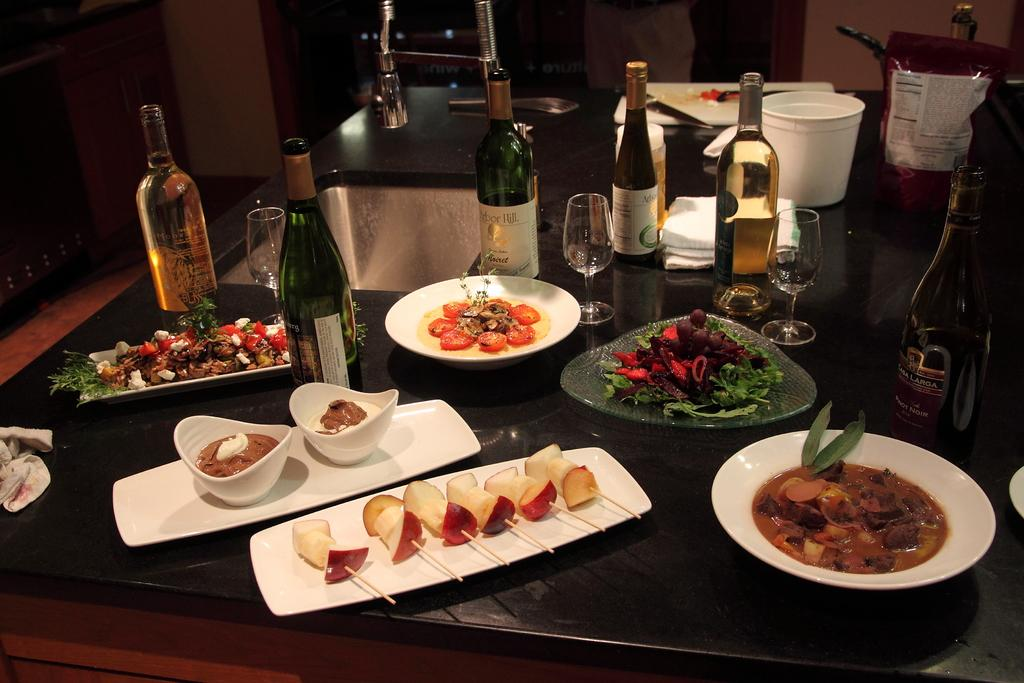What is the main piece of furniture in the image? There is a table in the image. What types of dishes are on the table? There are plates and bowls on the table. What types of beverages are on the table? There are bottles on the table. What types of drinking vessels are on the table? There are glasses on the table. What types of food are on the table? There are fruits and other food items on the table. How would you describe the lighting in the image? The image is slightly dark. What event is taking place at the table in the image? There is no specific event taking place at the table in the image; it simply shows various dishes, beverages, and food items. How does the digestion process appear in the image? The image does not depict the digestion process; it only shows the table with various items on it. 